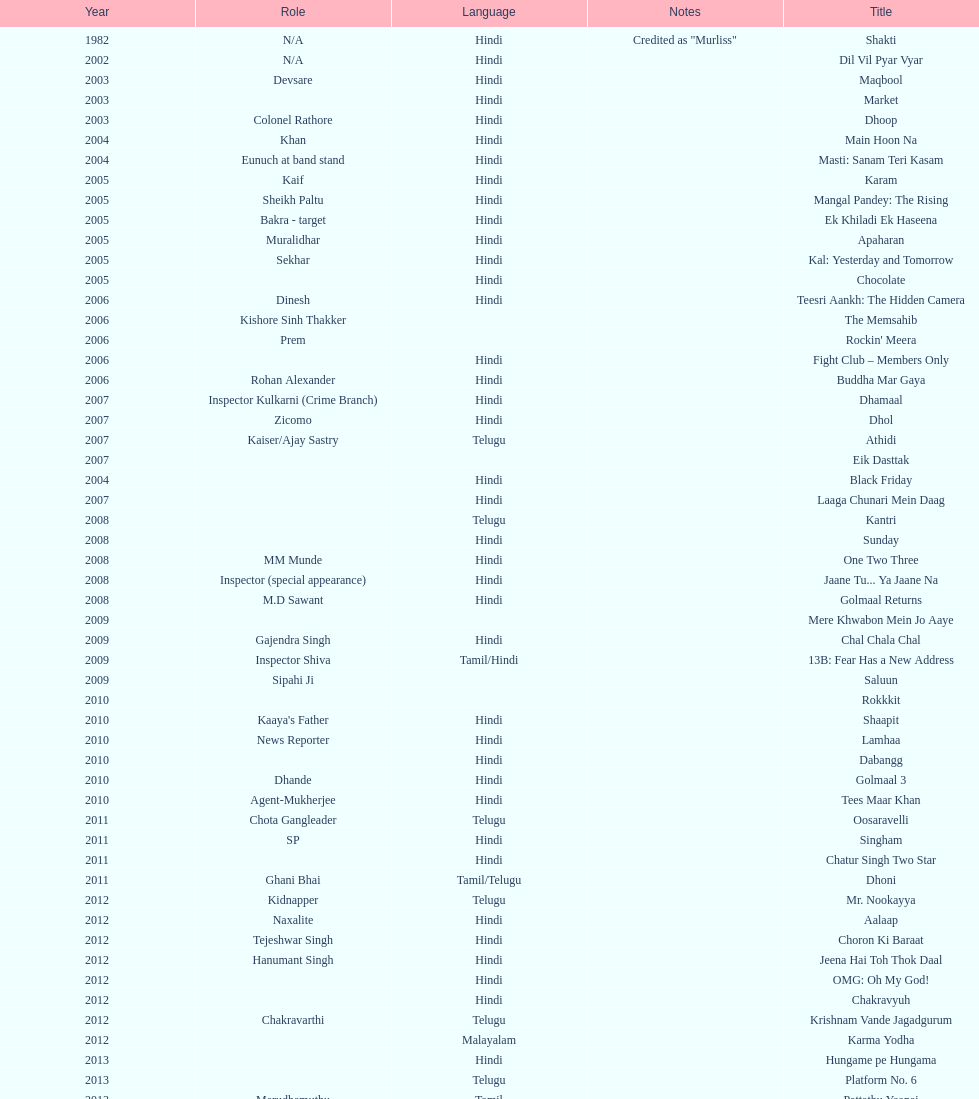What are the number of titles listed in 2005? 6. 